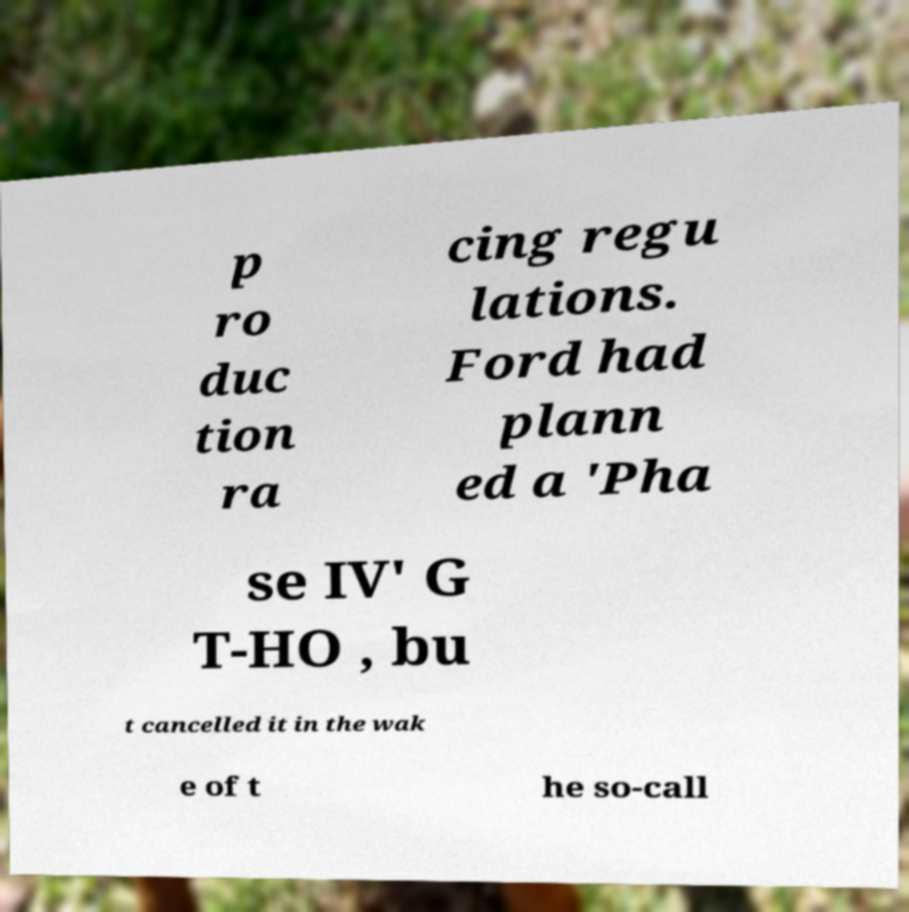I need the written content from this picture converted into text. Can you do that? p ro duc tion ra cing regu lations. Ford had plann ed a 'Pha se IV' G T-HO , bu t cancelled it in the wak e of t he so-call 